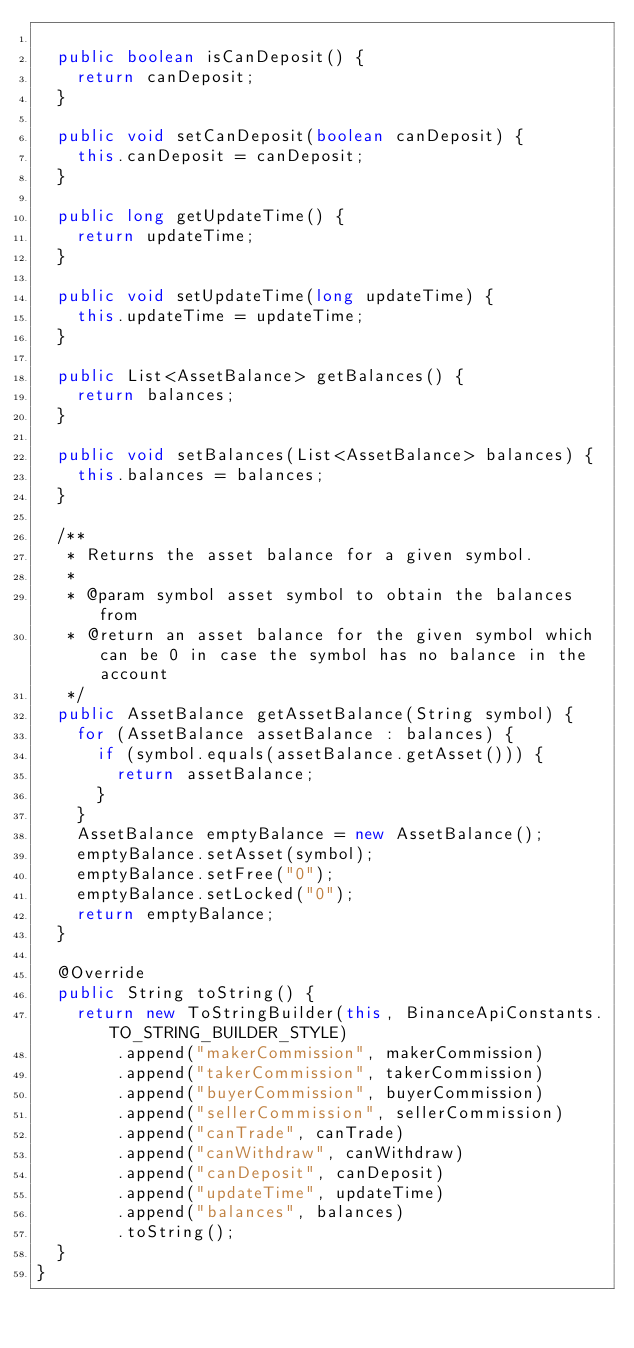<code> <loc_0><loc_0><loc_500><loc_500><_Java_>
  public boolean isCanDeposit() {
    return canDeposit;
  }

  public void setCanDeposit(boolean canDeposit) {
    this.canDeposit = canDeposit;
  }

  public long getUpdateTime() {
    return updateTime;
  }

  public void setUpdateTime(long updateTime) {
    this.updateTime = updateTime;
  }

  public List<AssetBalance> getBalances() {
    return balances;
  }

  public void setBalances(List<AssetBalance> balances) {
    this.balances = balances;
  }

  /**
   * Returns the asset balance for a given symbol.
   *
   * @param symbol asset symbol to obtain the balances from
   * @return an asset balance for the given symbol which can be 0 in case the symbol has no balance in the account
   */
  public AssetBalance getAssetBalance(String symbol) {
    for (AssetBalance assetBalance : balances) {
      if (symbol.equals(assetBalance.getAsset())) {
        return assetBalance;
      }
    }
    AssetBalance emptyBalance = new AssetBalance();
    emptyBalance.setAsset(symbol);
    emptyBalance.setFree("0");
    emptyBalance.setLocked("0");
    return emptyBalance;
  }

  @Override
  public String toString() {
    return new ToStringBuilder(this, BinanceApiConstants.TO_STRING_BUILDER_STYLE)
        .append("makerCommission", makerCommission)
        .append("takerCommission", takerCommission)
        .append("buyerCommission", buyerCommission)
        .append("sellerCommission", sellerCommission)
        .append("canTrade", canTrade)
        .append("canWithdraw", canWithdraw)
        .append("canDeposit", canDeposit)
        .append("updateTime", updateTime)
        .append("balances", balances)
        .toString();
  }
}
</code> 